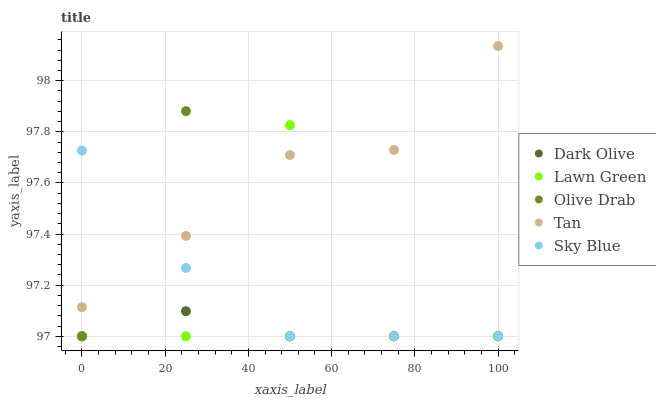Does Dark Olive have the minimum area under the curve?
Answer yes or no. Yes. Does Tan have the maximum area under the curve?
Answer yes or no. Yes. Does Tan have the minimum area under the curve?
Answer yes or no. No. Does Dark Olive have the maximum area under the curve?
Answer yes or no. No. Is Dark Olive the smoothest?
Answer yes or no. Yes. Is Lawn Green the roughest?
Answer yes or no. Yes. Is Tan the smoothest?
Answer yes or no. No. Is Tan the roughest?
Answer yes or no. No. Does Lawn Green have the lowest value?
Answer yes or no. Yes. Does Tan have the lowest value?
Answer yes or no. No. Does Tan have the highest value?
Answer yes or no. Yes. Does Dark Olive have the highest value?
Answer yes or no. No. Is Dark Olive less than Tan?
Answer yes or no. Yes. Is Tan greater than Dark Olive?
Answer yes or no. Yes. Does Olive Drab intersect Tan?
Answer yes or no. Yes. Is Olive Drab less than Tan?
Answer yes or no. No. Is Olive Drab greater than Tan?
Answer yes or no. No. Does Dark Olive intersect Tan?
Answer yes or no. No. 